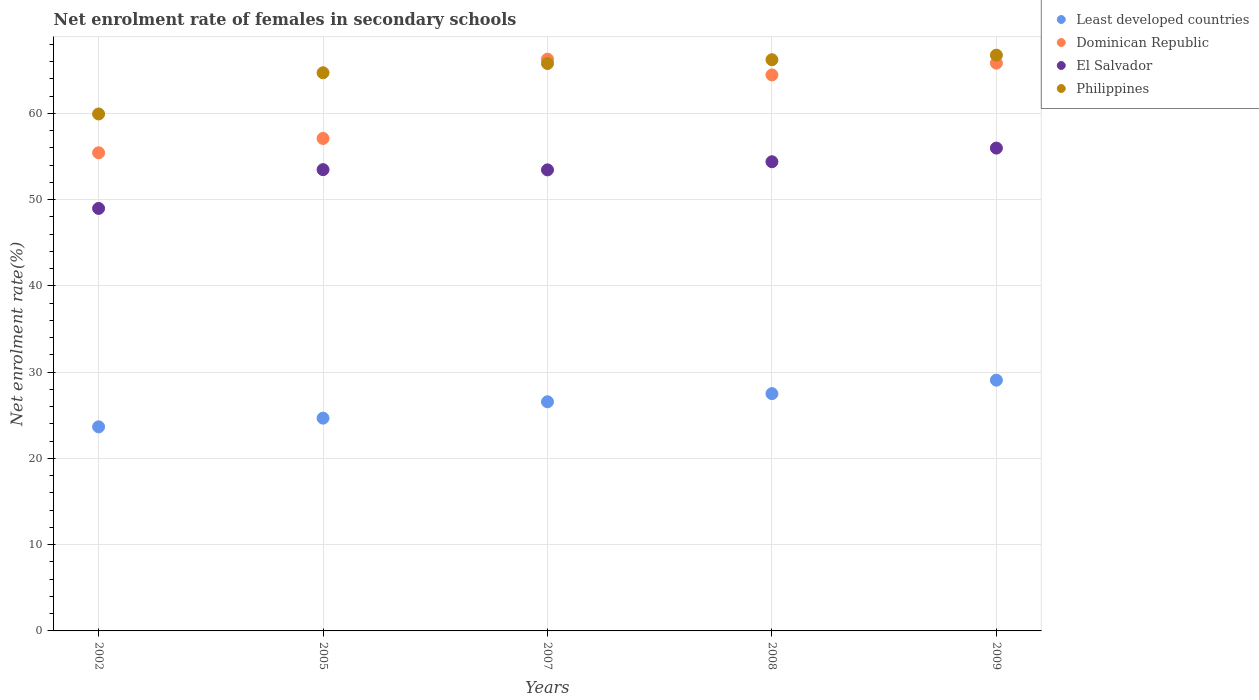How many different coloured dotlines are there?
Offer a very short reply. 4. What is the net enrolment rate of females in secondary schools in El Salvador in 2008?
Provide a short and direct response. 54.39. Across all years, what is the maximum net enrolment rate of females in secondary schools in Least developed countries?
Make the answer very short. 29.07. Across all years, what is the minimum net enrolment rate of females in secondary schools in Least developed countries?
Provide a short and direct response. 23.66. In which year was the net enrolment rate of females in secondary schools in Dominican Republic maximum?
Give a very brief answer. 2007. What is the total net enrolment rate of females in secondary schools in El Salvador in the graph?
Offer a very short reply. 266.25. What is the difference between the net enrolment rate of females in secondary schools in Least developed countries in 2005 and that in 2008?
Your answer should be very brief. -2.84. What is the difference between the net enrolment rate of females in secondary schools in Dominican Republic in 2002 and the net enrolment rate of females in secondary schools in Least developed countries in 2007?
Your answer should be very brief. 28.87. What is the average net enrolment rate of females in secondary schools in Philippines per year?
Make the answer very short. 64.67. In the year 2008, what is the difference between the net enrolment rate of females in secondary schools in El Salvador and net enrolment rate of females in secondary schools in Least developed countries?
Offer a very short reply. 26.88. In how many years, is the net enrolment rate of females in secondary schools in Dominican Republic greater than 58 %?
Ensure brevity in your answer.  3. What is the ratio of the net enrolment rate of females in secondary schools in Dominican Republic in 2002 to that in 2009?
Your answer should be compact. 0.84. Is the difference between the net enrolment rate of females in secondary schools in El Salvador in 2007 and 2009 greater than the difference between the net enrolment rate of females in secondary schools in Least developed countries in 2007 and 2009?
Your answer should be compact. No. What is the difference between the highest and the second highest net enrolment rate of females in secondary schools in Dominican Republic?
Your answer should be compact. 0.46. What is the difference between the highest and the lowest net enrolment rate of females in secondary schools in Dominican Republic?
Keep it short and to the point. 10.85. In how many years, is the net enrolment rate of females in secondary schools in Philippines greater than the average net enrolment rate of females in secondary schools in Philippines taken over all years?
Your answer should be compact. 4. Is it the case that in every year, the sum of the net enrolment rate of females in secondary schools in Dominican Republic and net enrolment rate of females in secondary schools in Philippines  is greater than the sum of net enrolment rate of females in secondary schools in Least developed countries and net enrolment rate of females in secondary schools in El Salvador?
Provide a succinct answer. Yes. Is it the case that in every year, the sum of the net enrolment rate of females in secondary schools in El Salvador and net enrolment rate of females in secondary schools in Philippines  is greater than the net enrolment rate of females in secondary schools in Least developed countries?
Your answer should be compact. Yes. How many years are there in the graph?
Offer a terse response. 5. Are the values on the major ticks of Y-axis written in scientific E-notation?
Offer a very short reply. No. Does the graph contain any zero values?
Ensure brevity in your answer.  No. How are the legend labels stacked?
Provide a short and direct response. Vertical. What is the title of the graph?
Offer a terse response. Net enrolment rate of females in secondary schools. What is the label or title of the X-axis?
Ensure brevity in your answer.  Years. What is the label or title of the Y-axis?
Keep it short and to the point. Net enrolment rate(%). What is the Net enrolment rate(%) in Least developed countries in 2002?
Offer a very short reply. 23.66. What is the Net enrolment rate(%) of Dominican Republic in 2002?
Provide a succinct answer. 55.43. What is the Net enrolment rate(%) of El Salvador in 2002?
Provide a succinct answer. 48.98. What is the Net enrolment rate(%) in Philippines in 2002?
Ensure brevity in your answer.  59.93. What is the Net enrolment rate(%) in Least developed countries in 2005?
Provide a short and direct response. 24.67. What is the Net enrolment rate(%) of Dominican Republic in 2005?
Offer a very short reply. 57.09. What is the Net enrolment rate(%) in El Salvador in 2005?
Provide a short and direct response. 53.47. What is the Net enrolment rate(%) of Philippines in 2005?
Your answer should be very brief. 64.7. What is the Net enrolment rate(%) in Least developed countries in 2007?
Keep it short and to the point. 26.56. What is the Net enrolment rate(%) in Dominican Republic in 2007?
Keep it short and to the point. 66.27. What is the Net enrolment rate(%) of El Salvador in 2007?
Your answer should be very brief. 53.44. What is the Net enrolment rate(%) of Philippines in 2007?
Offer a very short reply. 65.77. What is the Net enrolment rate(%) of Least developed countries in 2008?
Keep it short and to the point. 27.5. What is the Net enrolment rate(%) in Dominican Republic in 2008?
Make the answer very short. 64.45. What is the Net enrolment rate(%) in El Salvador in 2008?
Offer a terse response. 54.39. What is the Net enrolment rate(%) of Philippines in 2008?
Your answer should be compact. 66.21. What is the Net enrolment rate(%) of Least developed countries in 2009?
Offer a very short reply. 29.07. What is the Net enrolment rate(%) of Dominican Republic in 2009?
Offer a terse response. 65.81. What is the Net enrolment rate(%) in El Salvador in 2009?
Keep it short and to the point. 55.97. What is the Net enrolment rate(%) in Philippines in 2009?
Make the answer very short. 66.74. Across all years, what is the maximum Net enrolment rate(%) in Least developed countries?
Give a very brief answer. 29.07. Across all years, what is the maximum Net enrolment rate(%) of Dominican Republic?
Offer a terse response. 66.27. Across all years, what is the maximum Net enrolment rate(%) of El Salvador?
Give a very brief answer. 55.97. Across all years, what is the maximum Net enrolment rate(%) of Philippines?
Provide a succinct answer. 66.74. Across all years, what is the minimum Net enrolment rate(%) in Least developed countries?
Your answer should be very brief. 23.66. Across all years, what is the minimum Net enrolment rate(%) of Dominican Republic?
Provide a succinct answer. 55.43. Across all years, what is the minimum Net enrolment rate(%) in El Salvador?
Your response must be concise. 48.98. Across all years, what is the minimum Net enrolment rate(%) in Philippines?
Provide a short and direct response. 59.93. What is the total Net enrolment rate(%) of Least developed countries in the graph?
Keep it short and to the point. 131.46. What is the total Net enrolment rate(%) of Dominican Republic in the graph?
Give a very brief answer. 309.05. What is the total Net enrolment rate(%) in El Salvador in the graph?
Provide a succinct answer. 266.25. What is the total Net enrolment rate(%) in Philippines in the graph?
Provide a succinct answer. 323.35. What is the difference between the Net enrolment rate(%) of Least developed countries in 2002 and that in 2005?
Your answer should be very brief. -1.01. What is the difference between the Net enrolment rate(%) of Dominican Republic in 2002 and that in 2005?
Make the answer very short. -1.66. What is the difference between the Net enrolment rate(%) in El Salvador in 2002 and that in 2005?
Your response must be concise. -4.5. What is the difference between the Net enrolment rate(%) in Philippines in 2002 and that in 2005?
Your response must be concise. -4.77. What is the difference between the Net enrolment rate(%) of Least developed countries in 2002 and that in 2007?
Ensure brevity in your answer.  -2.9. What is the difference between the Net enrolment rate(%) of Dominican Republic in 2002 and that in 2007?
Offer a terse response. -10.85. What is the difference between the Net enrolment rate(%) in El Salvador in 2002 and that in 2007?
Your response must be concise. -4.47. What is the difference between the Net enrolment rate(%) of Philippines in 2002 and that in 2007?
Make the answer very short. -5.84. What is the difference between the Net enrolment rate(%) in Least developed countries in 2002 and that in 2008?
Provide a succinct answer. -3.85. What is the difference between the Net enrolment rate(%) of Dominican Republic in 2002 and that in 2008?
Ensure brevity in your answer.  -9.02. What is the difference between the Net enrolment rate(%) of El Salvador in 2002 and that in 2008?
Provide a short and direct response. -5.41. What is the difference between the Net enrolment rate(%) of Philippines in 2002 and that in 2008?
Your answer should be compact. -6.29. What is the difference between the Net enrolment rate(%) of Least developed countries in 2002 and that in 2009?
Offer a very short reply. -5.41. What is the difference between the Net enrolment rate(%) in Dominican Republic in 2002 and that in 2009?
Give a very brief answer. -10.39. What is the difference between the Net enrolment rate(%) of El Salvador in 2002 and that in 2009?
Ensure brevity in your answer.  -6.99. What is the difference between the Net enrolment rate(%) of Philippines in 2002 and that in 2009?
Give a very brief answer. -6.82. What is the difference between the Net enrolment rate(%) of Least developed countries in 2005 and that in 2007?
Keep it short and to the point. -1.9. What is the difference between the Net enrolment rate(%) of Dominican Republic in 2005 and that in 2007?
Offer a terse response. -9.19. What is the difference between the Net enrolment rate(%) in El Salvador in 2005 and that in 2007?
Offer a very short reply. 0.03. What is the difference between the Net enrolment rate(%) in Philippines in 2005 and that in 2007?
Give a very brief answer. -1.07. What is the difference between the Net enrolment rate(%) in Least developed countries in 2005 and that in 2008?
Provide a succinct answer. -2.84. What is the difference between the Net enrolment rate(%) of Dominican Republic in 2005 and that in 2008?
Give a very brief answer. -7.36. What is the difference between the Net enrolment rate(%) of El Salvador in 2005 and that in 2008?
Give a very brief answer. -0.92. What is the difference between the Net enrolment rate(%) in Philippines in 2005 and that in 2008?
Give a very brief answer. -1.51. What is the difference between the Net enrolment rate(%) of Least developed countries in 2005 and that in 2009?
Offer a terse response. -4.4. What is the difference between the Net enrolment rate(%) of Dominican Republic in 2005 and that in 2009?
Offer a very short reply. -8.73. What is the difference between the Net enrolment rate(%) in El Salvador in 2005 and that in 2009?
Keep it short and to the point. -2.5. What is the difference between the Net enrolment rate(%) of Philippines in 2005 and that in 2009?
Offer a very short reply. -2.04. What is the difference between the Net enrolment rate(%) in Least developed countries in 2007 and that in 2008?
Your answer should be very brief. -0.94. What is the difference between the Net enrolment rate(%) of Dominican Republic in 2007 and that in 2008?
Provide a succinct answer. 1.83. What is the difference between the Net enrolment rate(%) of El Salvador in 2007 and that in 2008?
Ensure brevity in your answer.  -0.94. What is the difference between the Net enrolment rate(%) of Philippines in 2007 and that in 2008?
Keep it short and to the point. -0.44. What is the difference between the Net enrolment rate(%) in Least developed countries in 2007 and that in 2009?
Your response must be concise. -2.51. What is the difference between the Net enrolment rate(%) in Dominican Republic in 2007 and that in 2009?
Your answer should be compact. 0.46. What is the difference between the Net enrolment rate(%) in El Salvador in 2007 and that in 2009?
Make the answer very short. -2.52. What is the difference between the Net enrolment rate(%) of Philippines in 2007 and that in 2009?
Your response must be concise. -0.97. What is the difference between the Net enrolment rate(%) of Least developed countries in 2008 and that in 2009?
Give a very brief answer. -1.57. What is the difference between the Net enrolment rate(%) of Dominican Republic in 2008 and that in 2009?
Keep it short and to the point. -1.37. What is the difference between the Net enrolment rate(%) in El Salvador in 2008 and that in 2009?
Your response must be concise. -1.58. What is the difference between the Net enrolment rate(%) in Philippines in 2008 and that in 2009?
Your response must be concise. -0.53. What is the difference between the Net enrolment rate(%) of Least developed countries in 2002 and the Net enrolment rate(%) of Dominican Republic in 2005?
Provide a short and direct response. -33.43. What is the difference between the Net enrolment rate(%) in Least developed countries in 2002 and the Net enrolment rate(%) in El Salvador in 2005?
Keep it short and to the point. -29.81. What is the difference between the Net enrolment rate(%) of Least developed countries in 2002 and the Net enrolment rate(%) of Philippines in 2005?
Ensure brevity in your answer.  -41.04. What is the difference between the Net enrolment rate(%) in Dominican Republic in 2002 and the Net enrolment rate(%) in El Salvador in 2005?
Your answer should be very brief. 1.96. What is the difference between the Net enrolment rate(%) of Dominican Republic in 2002 and the Net enrolment rate(%) of Philippines in 2005?
Keep it short and to the point. -9.27. What is the difference between the Net enrolment rate(%) of El Salvador in 2002 and the Net enrolment rate(%) of Philippines in 2005?
Make the answer very short. -15.72. What is the difference between the Net enrolment rate(%) in Least developed countries in 2002 and the Net enrolment rate(%) in Dominican Republic in 2007?
Make the answer very short. -42.62. What is the difference between the Net enrolment rate(%) of Least developed countries in 2002 and the Net enrolment rate(%) of El Salvador in 2007?
Provide a succinct answer. -29.79. What is the difference between the Net enrolment rate(%) of Least developed countries in 2002 and the Net enrolment rate(%) of Philippines in 2007?
Provide a succinct answer. -42.11. What is the difference between the Net enrolment rate(%) of Dominican Republic in 2002 and the Net enrolment rate(%) of El Salvador in 2007?
Offer a very short reply. 1.98. What is the difference between the Net enrolment rate(%) of Dominican Republic in 2002 and the Net enrolment rate(%) of Philippines in 2007?
Offer a terse response. -10.34. What is the difference between the Net enrolment rate(%) of El Salvador in 2002 and the Net enrolment rate(%) of Philippines in 2007?
Offer a very short reply. -16.79. What is the difference between the Net enrolment rate(%) in Least developed countries in 2002 and the Net enrolment rate(%) in Dominican Republic in 2008?
Make the answer very short. -40.79. What is the difference between the Net enrolment rate(%) in Least developed countries in 2002 and the Net enrolment rate(%) in El Salvador in 2008?
Your response must be concise. -30.73. What is the difference between the Net enrolment rate(%) in Least developed countries in 2002 and the Net enrolment rate(%) in Philippines in 2008?
Provide a succinct answer. -42.55. What is the difference between the Net enrolment rate(%) in Dominican Republic in 2002 and the Net enrolment rate(%) in El Salvador in 2008?
Provide a short and direct response. 1.04. What is the difference between the Net enrolment rate(%) in Dominican Republic in 2002 and the Net enrolment rate(%) in Philippines in 2008?
Ensure brevity in your answer.  -10.79. What is the difference between the Net enrolment rate(%) of El Salvador in 2002 and the Net enrolment rate(%) of Philippines in 2008?
Make the answer very short. -17.24. What is the difference between the Net enrolment rate(%) of Least developed countries in 2002 and the Net enrolment rate(%) of Dominican Republic in 2009?
Offer a terse response. -42.16. What is the difference between the Net enrolment rate(%) of Least developed countries in 2002 and the Net enrolment rate(%) of El Salvador in 2009?
Make the answer very short. -32.31. What is the difference between the Net enrolment rate(%) in Least developed countries in 2002 and the Net enrolment rate(%) in Philippines in 2009?
Ensure brevity in your answer.  -43.08. What is the difference between the Net enrolment rate(%) in Dominican Republic in 2002 and the Net enrolment rate(%) in El Salvador in 2009?
Provide a short and direct response. -0.54. What is the difference between the Net enrolment rate(%) of Dominican Republic in 2002 and the Net enrolment rate(%) of Philippines in 2009?
Make the answer very short. -11.31. What is the difference between the Net enrolment rate(%) of El Salvador in 2002 and the Net enrolment rate(%) of Philippines in 2009?
Your answer should be very brief. -17.77. What is the difference between the Net enrolment rate(%) in Least developed countries in 2005 and the Net enrolment rate(%) in Dominican Republic in 2007?
Ensure brevity in your answer.  -41.61. What is the difference between the Net enrolment rate(%) in Least developed countries in 2005 and the Net enrolment rate(%) in El Salvador in 2007?
Your answer should be compact. -28.78. What is the difference between the Net enrolment rate(%) of Least developed countries in 2005 and the Net enrolment rate(%) of Philippines in 2007?
Provide a succinct answer. -41.1. What is the difference between the Net enrolment rate(%) in Dominican Republic in 2005 and the Net enrolment rate(%) in El Salvador in 2007?
Your response must be concise. 3.64. What is the difference between the Net enrolment rate(%) of Dominican Republic in 2005 and the Net enrolment rate(%) of Philippines in 2007?
Ensure brevity in your answer.  -8.68. What is the difference between the Net enrolment rate(%) of El Salvador in 2005 and the Net enrolment rate(%) of Philippines in 2007?
Your response must be concise. -12.3. What is the difference between the Net enrolment rate(%) of Least developed countries in 2005 and the Net enrolment rate(%) of Dominican Republic in 2008?
Provide a succinct answer. -39.78. What is the difference between the Net enrolment rate(%) of Least developed countries in 2005 and the Net enrolment rate(%) of El Salvador in 2008?
Your answer should be very brief. -29.72. What is the difference between the Net enrolment rate(%) of Least developed countries in 2005 and the Net enrolment rate(%) of Philippines in 2008?
Your answer should be compact. -41.55. What is the difference between the Net enrolment rate(%) in Dominican Republic in 2005 and the Net enrolment rate(%) in El Salvador in 2008?
Offer a very short reply. 2.7. What is the difference between the Net enrolment rate(%) of Dominican Republic in 2005 and the Net enrolment rate(%) of Philippines in 2008?
Provide a succinct answer. -9.13. What is the difference between the Net enrolment rate(%) in El Salvador in 2005 and the Net enrolment rate(%) in Philippines in 2008?
Offer a terse response. -12.74. What is the difference between the Net enrolment rate(%) of Least developed countries in 2005 and the Net enrolment rate(%) of Dominican Republic in 2009?
Offer a very short reply. -41.15. What is the difference between the Net enrolment rate(%) of Least developed countries in 2005 and the Net enrolment rate(%) of El Salvador in 2009?
Your answer should be very brief. -31.3. What is the difference between the Net enrolment rate(%) of Least developed countries in 2005 and the Net enrolment rate(%) of Philippines in 2009?
Keep it short and to the point. -42.08. What is the difference between the Net enrolment rate(%) in Dominican Republic in 2005 and the Net enrolment rate(%) in El Salvador in 2009?
Make the answer very short. 1.12. What is the difference between the Net enrolment rate(%) of Dominican Republic in 2005 and the Net enrolment rate(%) of Philippines in 2009?
Your answer should be very brief. -9.66. What is the difference between the Net enrolment rate(%) of El Salvador in 2005 and the Net enrolment rate(%) of Philippines in 2009?
Keep it short and to the point. -13.27. What is the difference between the Net enrolment rate(%) in Least developed countries in 2007 and the Net enrolment rate(%) in Dominican Republic in 2008?
Offer a terse response. -37.89. What is the difference between the Net enrolment rate(%) of Least developed countries in 2007 and the Net enrolment rate(%) of El Salvador in 2008?
Provide a succinct answer. -27.82. What is the difference between the Net enrolment rate(%) of Least developed countries in 2007 and the Net enrolment rate(%) of Philippines in 2008?
Make the answer very short. -39.65. What is the difference between the Net enrolment rate(%) in Dominican Republic in 2007 and the Net enrolment rate(%) in El Salvador in 2008?
Your answer should be very brief. 11.89. What is the difference between the Net enrolment rate(%) in Dominican Republic in 2007 and the Net enrolment rate(%) in Philippines in 2008?
Ensure brevity in your answer.  0.06. What is the difference between the Net enrolment rate(%) of El Salvador in 2007 and the Net enrolment rate(%) of Philippines in 2008?
Give a very brief answer. -12.77. What is the difference between the Net enrolment rate(%) in Least developed countries in 2007 and the Net enrolment rate(%) in Dominican Republic in 2009?
Make the answer very short. -39.25. What is the difference between the Net enrolment rate(%) in Least developed countries in 2007 and the Net enrolment rate(%) in El Salvador in 2009?
Provide a succinct answer. -29.41. What is the difference between the Net enrolment rate(%) in Least developed countries in 2007 and the Net enrolment rate(%) in Philippines in 2009?
Provide a short and direct response. -40.18. What is the difference between the Net enrolment rate(%) of Dominican Republic in 2007 and the Net enrolment rate(%) of El Salvador in 2009?
Offer a very short reply. 10.31. What is the difference between the Net enrolment rate(%) of Dominican Republic in 2007 and the Net enrolment rate(%) of Philippines in 2009?
Provide a short and direct response. -0.47. What is the difference between the Net enrolment rate(%) of El Salvador in 2007 and the Net enrolment rate(%) of Philippines in 2009?
Your response must be concise. -13.3. What is the difference between the Net enrolment rate(%) of Least developed countries in 2008 and the Net enrolment rate(%) of Dominican Republic in 2009?
Offer a terse response. -38.31. What is the difference between the Net enrolment rate(%) of Least developed countries in 2008 and the Net enrolment rate(%) of El Salvador in 2009?
Make the answer very short. -28.46. What is the difference between the Net enrolment rate(%) in Least developed countries in 2008 and the Net enrolment rate(%) in Philippines in 2009?
Your answer should be very brief. -39.24. What is the difference between the Net enrolment rate(%) in Dominican Republic in 2008 and the Net enrolment rate(%) in El Salvador in 2009?
Give a very brief answer. 8.48. What is the difference between the Net enrolment rate(%) in Dominican Republic in 2008 and the Net enrolment rate(%) in Philippines in 2009?
Offer a terse response. -2.29. What is the difference between the Net enrolment rate(%) of El Salvador in 2008 and the Net enrolment rate(%) of Philippines in 2009?
Your answer should be compact. -12.36. What is the average Net enrolment rate(%) in Least developed countries per year?
Offer a terse response. 26.29. What is the average Net enrolment rate(%) in Dominican Republic per year?
Make the answer very short. 61.81. What is the average Net enrolment rate(%) in El Salvador per year?
Your answer should be very brief. 53.25. What is the average Net enrolment rate(%) in Philippines per year?
Your answer should be very brief. 64.67. In the year 2002, what is the difference between the Net enrolment rate(%) in Least developed countries and Net enrolment rate(%) in Dominican Republic?
Provide a short and direct response. -31.77. In the year 2002, what is the difference between the Net enrolment rate(%) in Least developed countries and Net enrolment rate(%) in El Salvador?
Provide a short and direct response. -25.32. In the year 2002, what is the difference between the Net enrolment rate(%) of Least developed countries and Net enrolment rate(%) of Philippines?
Provide a short and direct response. -36.27. In the year 2002, what is the difference between the Net enrolment rate(%) in Dominican Republic and Net enrolment rate(%) in El Salvador?
Make the answer very short. 6.45. In the year 2002, what is the difference between the Net enrolment rate(%) of Dominican Republic and Net enrolment rate(%) of Philippines?
Offer a very short reply. -4.5. In the year 2002, what is the difference between the Net enrolment rate(%) of El Salvador and Net enrolment rate(%) of Philippines?
Your answer should be compact. -10.95. In the year 2005, what is the difference between the Net enrolment rate(%) in Least developed countries and Net enrolment rate(%) in Dominican Republic?
Offer a very short reply. -32.42. In the year 2005, what is the difference between the Net enrolment rate(%) of Least developed countries and Net enrolment rate(%) of El Salvador?
Provide a succinct answer. -28.8. In the year 2005, what is the difference between the Net enrolment rate(%) of Least developed countries and Net enrolment rate(%) of Philippines?
Your answer should be compact. -40.03. In the year 2005, what is the difference between the Net enrolment rate(%) of Dominican Republic and Net enrolment rate(%) of El Salvador?
Give a very brief answer. 3.62. In the year 2005, what is the difference between the Net enrolment rate(%) of Dominican Republic and Net enrolment rate(%) of Philippines?
Offer a very short reply. -7.61. In the year 2005, what is the difference between the Net enrolment rate(%) of El Salvador and Net enrolment rate(%) of Philippines?
Provide a succinct answer. -11.23. In the year 2007, what is the difference between the Net enrolment rate(%) in Least developed countries and Net enrolment rate(%) in Dominican Republic?
Your answer should be compact. -39.71. In the year 2007, what is the difference between the Net enrolment rate(%) of Least developed countries and Net enrolment rate(%) of El Salvador?
Provide a succinct answer. -26.88. In the year 2007, what is the difference between the Net enrolment rate(%) of Least developed countries and Net enrolment rate(%) of Philippines?
Your response must be concise. -39.21. In the year 2007, what is the difference between the Net enrolment rate(%) of Dominican Republic and Net enrolment rate(%) of El Salvador?
Ensure brevity in your answer.  12.83. In the year 2007, what is the difference between the Net enrolment rate(%) in Dominican Republic and Net enrolment rate(%) in Philippines?
Make the answer very short. 0.5. In the year 2007, what is the difference between the Net enrolment rate(%) in El Salvador and Net enrolment rate(%) in Philippines?
Your answer should be compact. -12.33. In the year 2008, what is the difference between the Net enrolment rate(%) of Least developed countries and Net enrolment rate(%) of Dominican Republic?
Your answer should be very brief. -36.94. In the year 2008, what is the difference between the Net enrolment rate(%) in Least developed countries and Net enrolment rate(%) in El Salvador?
Offer a terse response. -26.88. In the year 2008, what is the difference between the Net enrolment rate(%) in Least developed countries and Net enrolment rate(%) in Philippines?
Provide a succinct answer. -38.71. In the year 2008, what is the difference between the Net enrolment rate(%) in Dominican Republic and Net enrolment rate(%) in El Salvador?
Make the answer very short. 10.06. In the year 2008, what is the difference between the Net enrolment rate(%) in Dominican Republic and Net enrolment rate(%) in Philippines?
Make the answer very short. -1.76. In the year 2008, what is the difference between the Net enrolment rate(%) in El Salvador and Net enrolment rate(%) in Philippines?
Your answer should be compact. -11.83. In the year 2009, what is the difference between the Net enrolment rate(%) of Least developed countries and Net enrolment rate(%) of Dominican Republic?
Provide a succinct answer. -36.74. In the year 2009, what is the difference between the Net enrolment rate(%) in Least developed countries and Net enrolment rate(%) in El Salvador?
Make the answer very short. -26.9. In the year 2009, what is the difference between the Net enrolment rate(%) in Least developed countries and Net enrolment rate(%) in Philippines?
Offer a terse response. -37.67. In the year 2009, what is the difference between the Net enrolment rate(%) in Dominican Republic and Net enrolment rate(%) in El Salvador?
Your answer should be very brief. 9.85. In the year 2009, what is the difference between the Net enrolment rate(%) in Dominican Republic and Net enrolment rate(%) in Philippines?
Provide a succinct answer. -0.93. In the year 2009, what is the difference between the Net enrolment rate(%) of El Salvador and Net enrolment rate(%) of Philippines?
Keep it short and to the point. -10.77. What is the ratio of the Net enrolment rate(%) in Least developed countries in 2002 to that in 2005?
Give a very brief answer. 0.96. What is the ratio of the Net enrolment rate(%) of Dominican Republic in 2002 to that in 2005?
Give a very brief answer. 0.97. What is the ratio of the Net enrolment rate(%) of El Salvador in 2002 to that in 2005?
Your answer should be very brief. 0.92. What is the ratio of the Net enrolment rate(%) in Philippines in 2002 to that in 2005?
Your response must be concise. 0.93. What is the ratio of the Net enrolment rate(%) of Least developed countries in 2002 to that in 2007?
Your answer should be very brief. 0.89. What is the ratio of the Net enrolment rate(%) in Dominican Republic in 2002 to that in 2007?
Offer a terse response. 0.84. What is the ratio of the Net enrolment rate(%) in El Salvador in 2002 to that in 2007?
Make the answer very short. 0.92. What is the ratio of the Net enrolment rate(%) in Philippines in 2002 to that in 2007?
Ensure brevity in your answer.  0.91. What is the ratio of the Net enrolment rate(%) in Least developed countries in 2002 to that in 2008?
Ensure brevity in your answer.  0.86. What is the ratio of the Net enrolment rate(%) of Dominican Republic in 2002 to that in 2008?
Ensure brevity in your answer.  0.86. What is the ratio of the Net enrolment rate(%) of El Salvador in 2002 to that in 2008?
Make the answer very short. 0.9. What is the ratio of the Net enrolment rate(%) in Philippines in 2002 to that in 2008?
Offer a terse response. 0.91. What is the ratio of the Net enrolment rate(%) in Least developed countries in 2002 to that in 2009?
Make the answer very short. 0.81. What is the ratio of the Net enrolment rate(%) of Dominican Republic in 2002 to that in 2009?
Offer a terse response. 0.84. What is the ratio of the Net enrolment rate(%) of El Salvador in 2002 to that in 2009?
Your response must be concise. 0.88. What is the ratio of the Net enrolment rate(%) in Philippines in 2002 to that in 2009?
Ensure brevity in your answer.  0.9. What is the ratio of the Net enrolment rate(%) of Dominican Republic in 2005 to that in 2007?
Make the answer very short. 0.86. What is the ratio of the Net enrolment rate(%) in El Salvador in 2005 to that in 2007?
Your response must be concise. 1. What is the ratio of the Net enrolment rate(%) in Philippines in 2005 to that in 2007?
Offer a terse response. 0.98. What is the ratio of the Net enrolment rate(%) in Least developed countries in 2005 to that in 2008?
Provide a short and direct response. 0.9. What is the ratio of the Net enrolment rate(%) in Dominican Republic in 2005 to that in 2008?
Provide a succinct answer. 0.89. What is the ratio of the Net enrolment rate(%) in El Salvador in 2005 to that in 2008?
Offer a very short reply. 0.98. What is the ratio of the Net enrolment rate(%) in Philippines in 2005 to that in 2008?
Provide a short and direct response. 0.98. What is the ratio of the Net enrolment rate(%) in Least developed countries in 2005 to that in 2009?
Give a very brief answer. 0.85. What is the ratio of the Net enrolment rate(%) of Dominican Republic in 2005 to that in 2009?
Give a very brief answer. 0.87. What is the ratio of the Net enrolment rate(%) of El Salvador in 2005 to that in 2009?
Your answer should be very brief. 0.96. What is the ratio of the Net enrolment rate(%) in Philippines in 2005 to that in 2009?
Your answer should be very brief. 0.97. What is the ratio of the Net enrolment rate(%) of Least developed countries in 2007 to that in 2008?
Make the answer very short. 0.97. What is the ratio of the Net enrolment rate(%) of Dominican Republic in 2007 to that in 2008?
Keep it short and to the point. 1.03. What is the ratio of the Net enrolment rate(%) in El Salvador in 2007 to that in 2008?
Ensure brevity in your answer.  0.98. What is the ratio of the Net enrolment rate(%) in Least developed countries in 2007 to that in 2009?
Give a very brief answer. 0.91. What is the ratio of the Net enrolment rate(%) in Dominican Republic in 2007 to that in 2009?
Your response must be concise. 1.01. What is the ratio of the Net enrolment rate(%) of El Salvador in 2007 to that in 2009?
Your response must be concise. 0.95. What is the ratio of the Net enrolment rate(%) of Philippines in 2007 to that in 2009?
Your response must be concise. 0.99. What is the ratio of the Net enrolment rate(%) of Least developed countries in 2008 to that in 2009?
Keep it short and to the point. 0.95. What is the ratio of the Net enrolment rate(%) in Dominican Republic in 2008 to that in 2009?
Your answer should be very brief. 0.98. What is the ratio of the Net enrolment rate(%) in El Salvador in 2008 to that in 2009?
Your response must be concise. 0.97. What is the difference between the highest and the second highest Net enrolment rate(%) of Least developed countries?
Your response must be concise. 1.57. What is the difference between the highest and the second highest Net enrolment rate(%) in Dominican Republic?
Your response must be concise. 0.46. What is the difference between the highest and the second highest Net enrolment rate(%) of El Salvador?
Offer a very short reply. 1.58. What is the difference between the highest and the second highest Net enrolment rate(%) in Philippines?
Give a very brief answer. 0.53. What is the difference between the highest and the lowest Net enrolment rate(%) of Least developed countries?
Give a very brief answer. 5.41. What is the difference between the highest and the lowest Net enrolment rate(%) of Dominican Republic?
Give a very brief answer. 10.85. What is the difference between the highest and the lowest Net enrolment rate(%) in El Salvador?
Your answer should be very brief. 6.99. What is the difference between the highest and the lowest Net enrolment rate(%) of Philippines?
Provide a short and direct response. 6.82. 